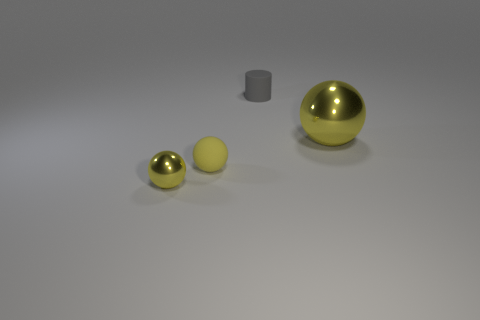Subtract all yellow metal spheres. How many spheres are left? 1 Add 3 matte cylinders. How many objects exist? 7 Subtract all spheres. How many objects are left? 1 Subtract all purple cylinders. Subtract all cyan blocks. How many cylinders are left? 1 Subtract all brown cylinders. How many cyan balls are left? 0 Subtract all large brown cylinders. Subtract all big shiny things. How many objects are left? 3 Add 1 small rubber balls. How many small rubber balls are left? 2 Add 2 gray cylinders. How many gray cylinders exist? 3 Subtract 0 yellow blocks. How many objects are left? 4 Subtract 2 spheres. How many spheres are left? 1 